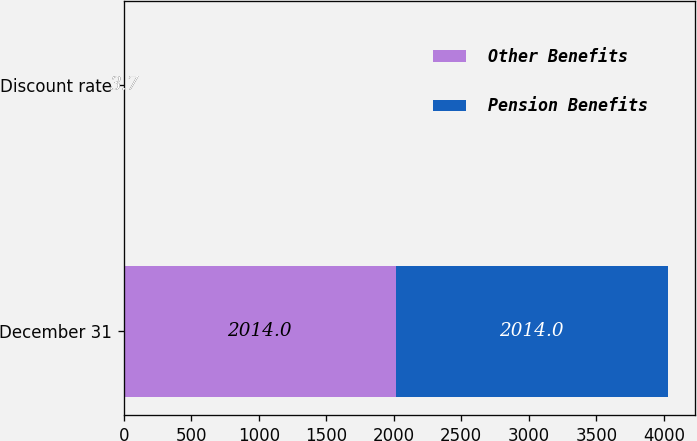Convert chart. <chart><loc_0><loc_0><loc_500><loc_500><stacked_bar_chart><ecel><fcel>December 31<fcel>Discount rate<nl><fcel>Other Benefits<fcel>2014<fcel>3.7<nl><fcel>Pension Benefits<fcel>2014<fcel>3.7<nl></chart> 